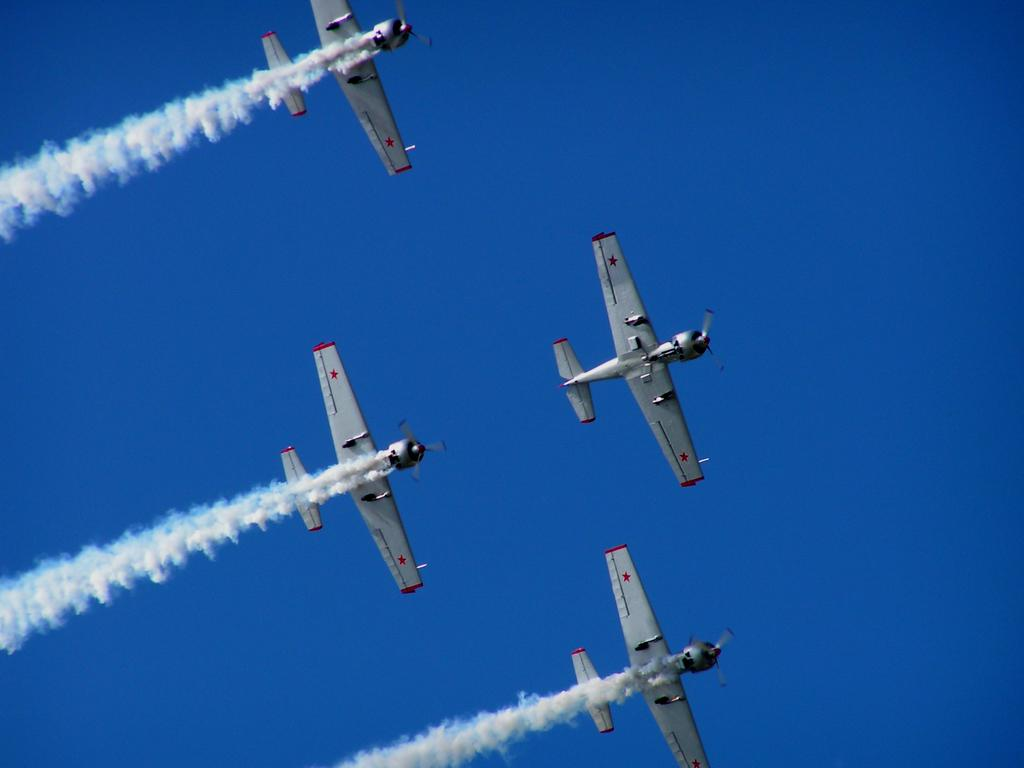How many air crafts can be seen in the image? There are four air crafts in the image. What colors are the air crafts? The air crafts are white and red in color. What are the air crafts doing in the image? The air crafts are flying in the air. What can be seen behind the air crafts? There is white colored smoke behind the air crafts. What is visible in the background of the image? The sky is visible in the background of the image. What type of jewel is being held by the parent in the image? There is no parent or jewel present in the image; it features four air crafts flying in the air with white colored smoke behind them. 